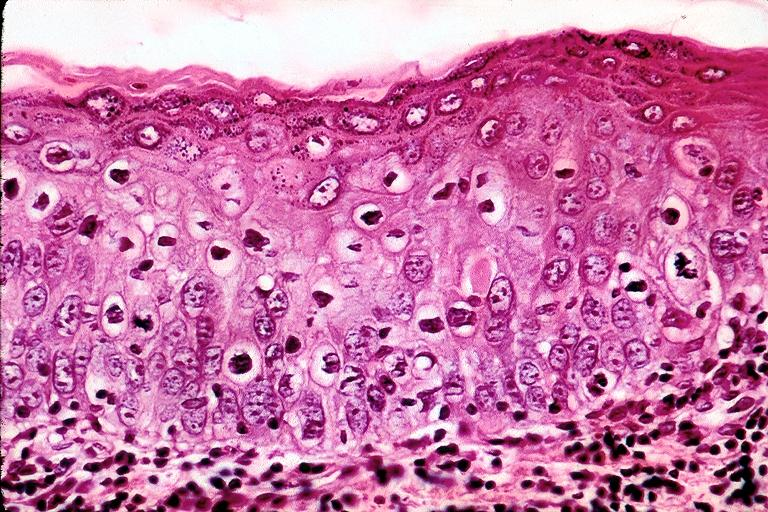where is this?
Answer the question using a single word or phrase. Oral 